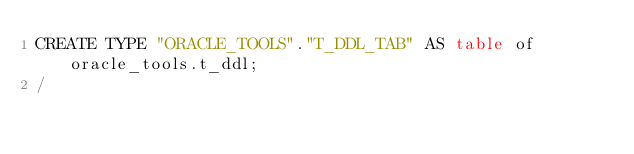Convert code to text. <code><loc_0><loc_0><loc_500><loc_500><_SQL_>CREATE TYPE "ORACLE_TOOLS"."T_DDL_TAB" AS table of oracle_tools.t_ddl;
/

</code> 